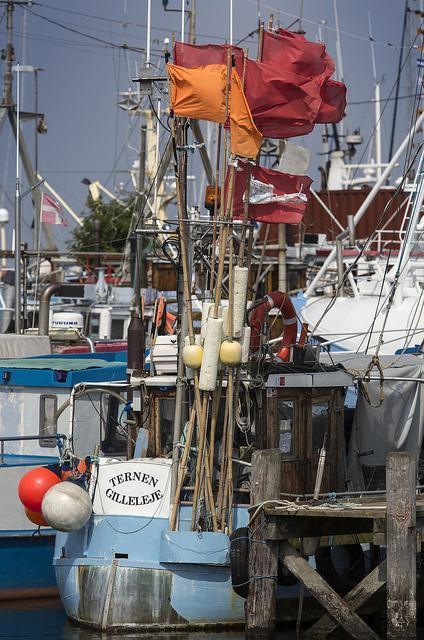How many balloons are there?
Give a very brief answer. 0. How many boats are there?
Give a very brief answer. 2. 